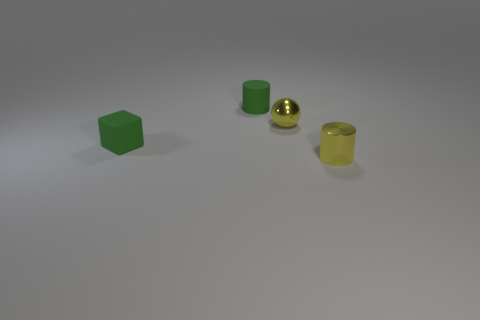The small shiny object that is the same color as the small shiny sphere is what shape?
Offer a very short reply. Cylinder. How many green objects are tiny balls or blocks?
Make the answer very short. 1. Does the tiny yellow cylinder have the same material as the yellow thing that is behind the tiny yellow shiny cylinder?
Offer a very short reply. Yes. What material is the tiny yellow sphere?
Keep it short and to the point. Metal. The green object that is in front of the rubber object behind the rubber object that is on the left side of the green rubber cylinder is made of what material?
Offer a very short reply. Rubber. What number of metallic objects are small green objects or small brown cubes?
Make the answer very short. 0. Is the number of small green matte blocks less than the number of tiny green objects?
Give a very brief answer. Yes. There is a rubber block; is its size the same as the yellow metal ball right of the tiny green cylinder?
Your answer should be very brief. Yes. What size is the yellow cylinder?
Keep it short and to the point. Small. Is the number of small green things left of the matte cylinder less than the number of small gray metal cubes?
Keep it short and to the point. No. 